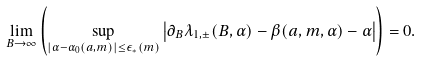<formula> <loc_0><loc_0><loc_500><loc_500>\lim _ { B \to \infty } \left ( \sup _ { | \alpha - \alpha _ { 0 } ( a , m ) | \leq \epsilon _ { * } ( m ) } \left | \partial _ { B } \lambda _ { 1 , \pm } ( B , \alpha ) - \beta ( a , m , \alpha ) - \alpha \right | \right ) = 0 .</formula> 